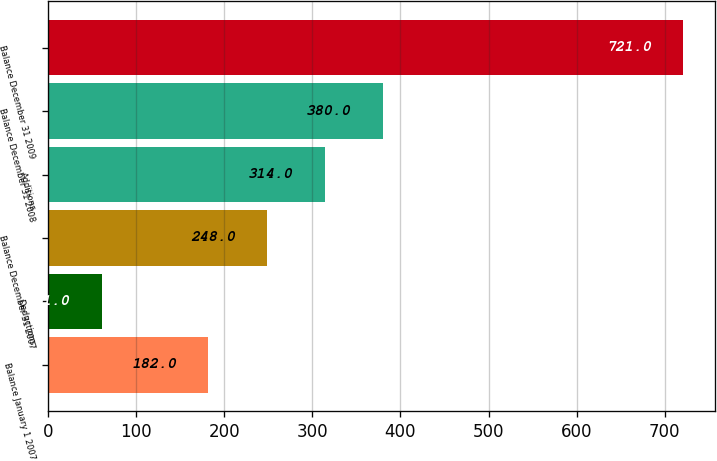Convert chart. <chart><loc_0><loc_0><loc_500><loc_500><bar_chart><fcel>Balance January 1 2007<fcel>Deductions<fcel>Balance December 31 2007<fcel>Additions<fcel>Balance December 31 2008<fcel>Balance December 31 2009<nl><fcel>182<fcel>61<fcel>248<fcel>314<fcel>380<fcel>721<nl></chart> 